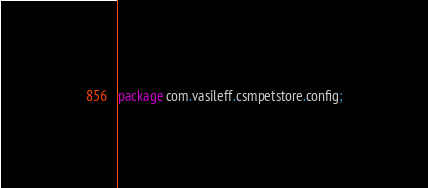Convert code to text. <code><loc_0><loc_0><loc_500><loc_500><_Ceylon_>package com.vasileff.csmpetstore.config;
</code> 